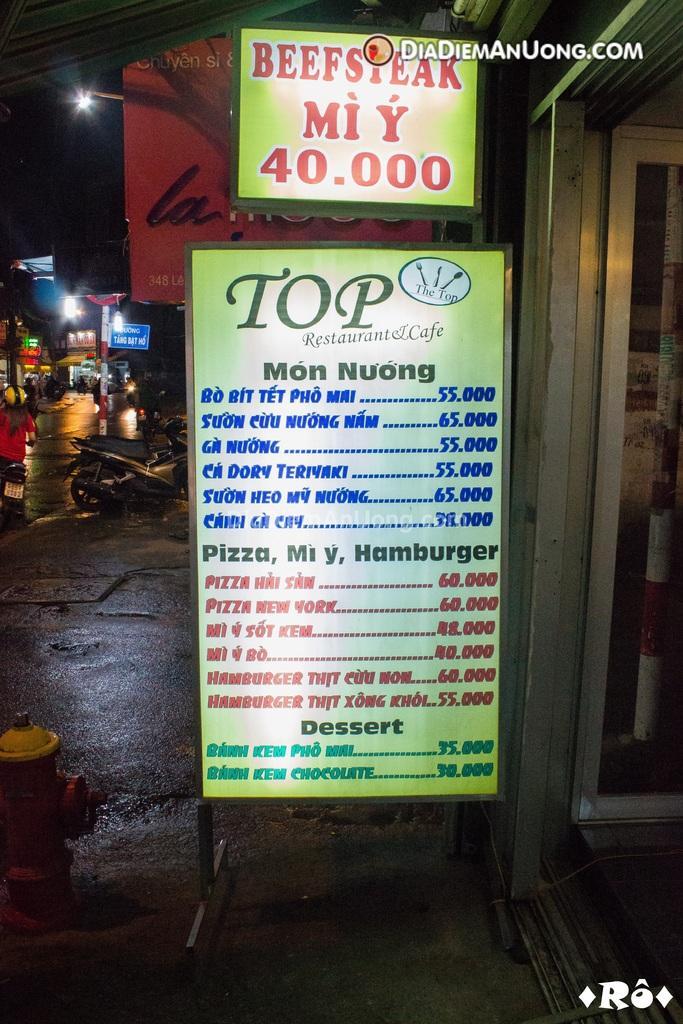Can you describe this image briefly? In this image we can see the boards with some text on it, there are some vehicles, lights, people and poles, also we can see a hydrant and a door. 